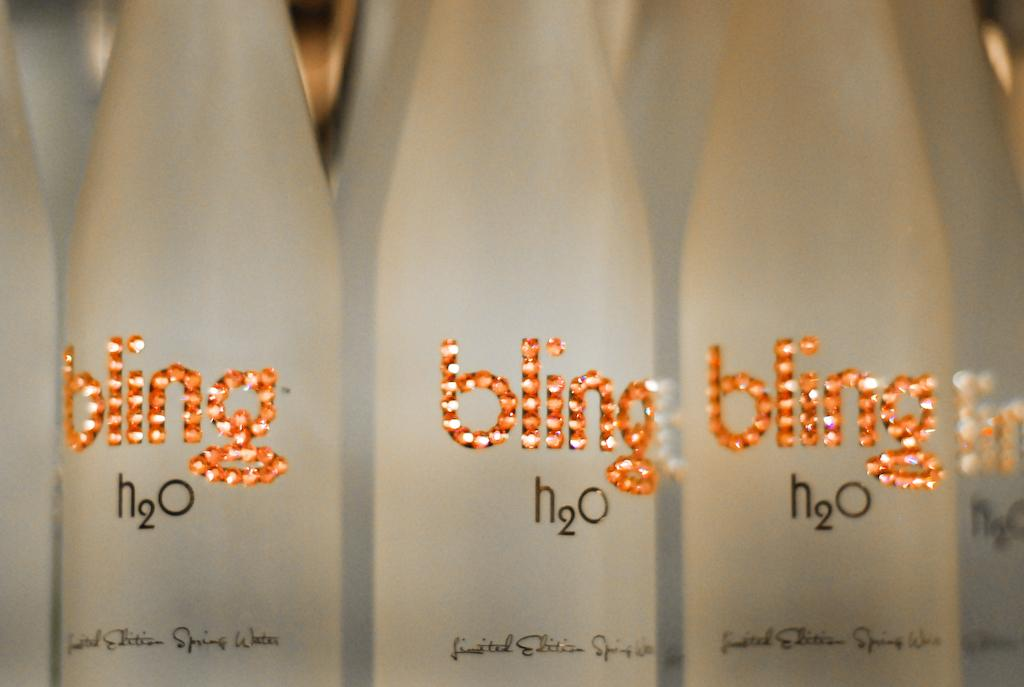<image>
Summarize the visual content of the image. Bottles of  water called Bling h20 spring water 